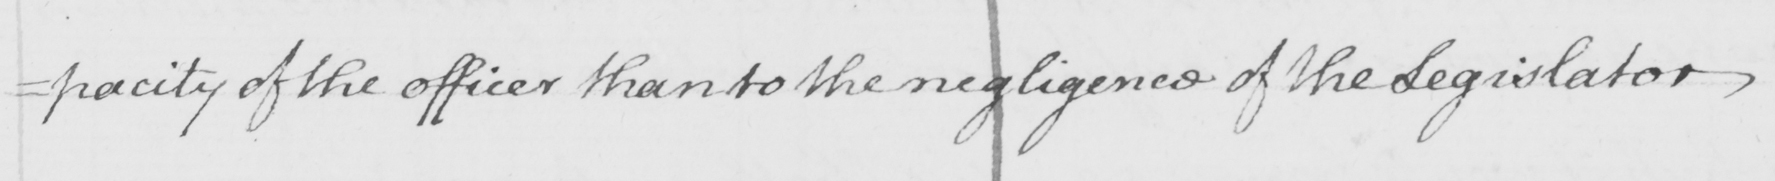Can you tell me what this handwritten text says? =pacity of the officer than to the negligence of the Legislator . 